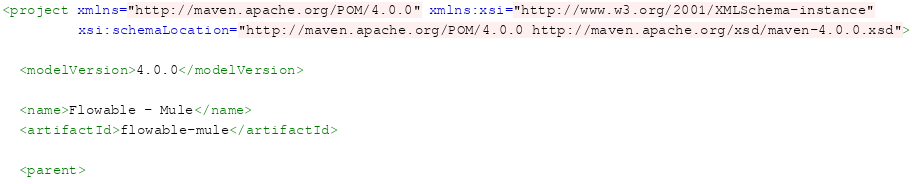Convert code to text. <code><loc_0><loc_0><loc_500><loc_500><_XML_><project xmlns="http://maven.apache.org/POM/4.0.0" xmlns:xsi="http://www.w3.org/2001/XMLSchema-instance"
         xsi:schemaLocation="http://maven.apache.org/POM/4.0.0 http://maven.apache.org/xsd/maven-4.0.0.xsd">

  <modelVersion>4.0.0</modelVersion>

  <name>Flowable - Mule</name>
  <artifactId>flowable-mule</artifactId>

  <parent></code> 